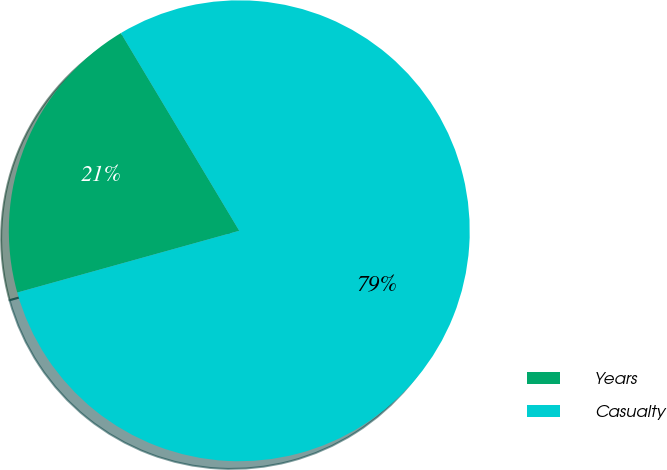<chart> <loc_0><loc_0><loc_500><loc_500><pie_chart><fcel>Years<fcel>Casualty<nl><fcel>20.73%<fcel>79.27%<nl></chart> 